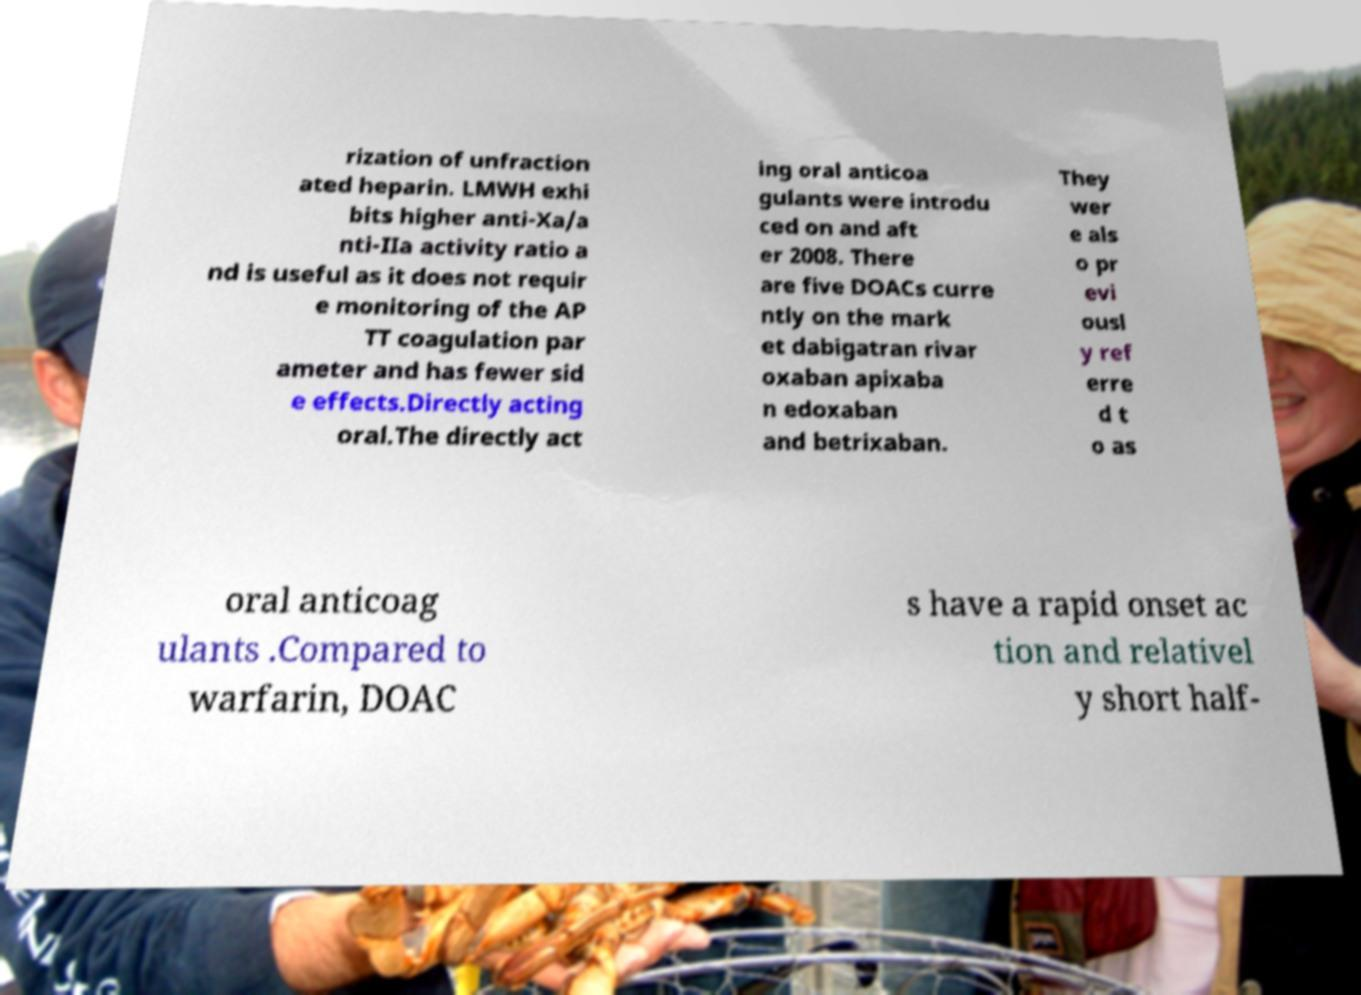There's text embedded in this image that I need extracted. Can you transcribe it verbatim? rization of unfraction ated heparin. LMWH exhi bits higher anti-Xa/a nti-IIa activity ratio a nd is useful as it does not requir e monitoring of the AP TT coagulation par ameter and has fewer sid e effects.Directly acting oral.The directly act ing oral anticoa gulants were introdu ced on and aft er 2008. There are five DOACs curre ntly on the mark et dabigatran rivar oxaban apixaba n edoxaban and betrixaban. They wer e als o pr evi ousl y ref erre d t o as oral anticoag ulants .Compared to warfarin, DOAC s have a rapid onset ac tion and relativel y short half- 